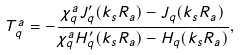<formula> <loc_0><loc_0><loc_500><loc_500>T _ { q } ^ { a } = - \frac { \chi _ { q } ^ { a } J _ { q } ^ { \prime } ( k _ { s } R _ { a } ) - J _ { q } ( k _ { s } R _ { a } ) } { \chi _ { q } ^ { a } H _ { q } ^ { \prime } ( k _ { s } R _ { a } ) - H _ { q } ( k _ { s } R _ { a } ) } ,</formula> 